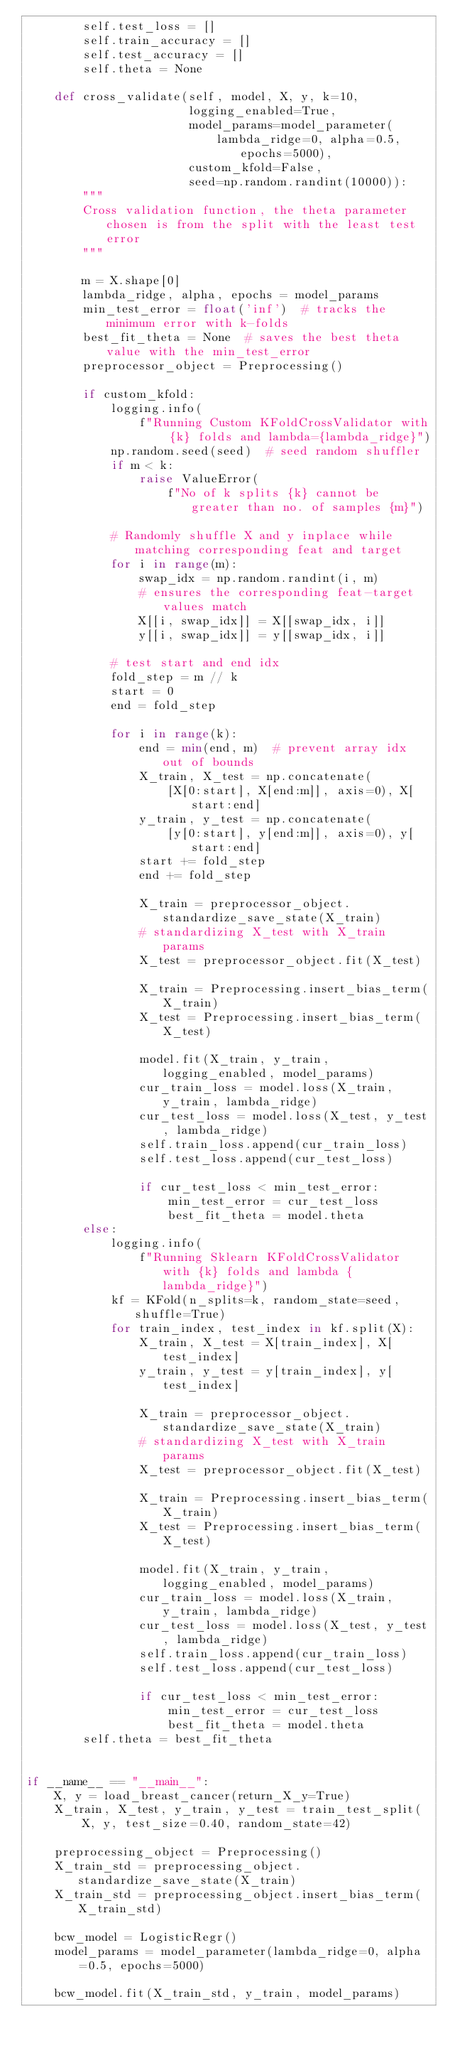<code> <loc_0><loc_0><loc_500><loc_500><_Python_>        self.test_loss = []
        self.train_accuracy = []
        self.test_accuracy = []
        self.theta = None

    def cross_validate(self, model, X, y, k=10,
                       logging_enabled=True,
                       model_params=model_parameter(
                           lambda_ridge=0, alpha=0.5, epochs=5000),
                       custom_kfold=False,
                       seed=np.random.randint(10000)):
        """
        Cross validation function, the theta parameter chosen is from the split with the least test error
        """

        m = X.shape[0]
        lambda_ridge, alpha, epochs = model_params
        min_test_error = float('inf')  # tracks the minimum error with k-folds
        best_fit_theta = None  # saves the best theta value with the min_test_error
        preprocessor_object = Preprocessing()

        if custom_kfold:
            logging.info(
                f"Running Custom KFoldCrossValidator with {k} folds and lambda={lambda_ridge}")
            np.random.seed(seed)  # seed random shuffler
            if m < k:
                raise ValueError(
                    f"No of k splits {k} cannot be greater than no. of samples {m}")

            # Randomly shuffle X and y inplace while matching corresponding feat and target
            for i in range(m):
                swap_idx = np.random.randint(i, m)
                # ensures the corresponding feat-target values match
                X[[i, swap_idx]] = X[[swap_idx, i]]
                y[[i, swap_idx]] = y[[swap_idx, i]]

            # test start and end idx
            fold_step = m // k
            start = 0
            end = fold_step

            for i in range(k):
                end = min(end, m)  # prevent array idx out of bounds
                X_train, X_test = np.concatenate(
                    [X[0:start], X[end:m]], axis=0), X[start:end]
                y_train, y_test = np.concatenate(
                    [y[0:start], y[end:m]], axis=0), y[start:end]
                start += fold_step
                end += fold_step

                X_train = preprocessor_object.standardize_save_state(X_train)
                # standardizing X_test with X_train params
                X_test = preprocessor_object.fit(X_test)

                X_train = Preprocessing.insert_bias_term(X_train)
                X_test = Preprocessing.insert_bias_term(X_test)

                model.fit(X_train, y_train, logging_enabled, model_params)
                cur_train_loss = model.loss(X_train, y_train, lambda_ridge)
                cur_test_loss = model.loss(X_test, y_test, lambda_ridge)
                self.train_loss.append(cur_train_loss)
                self.test_loss.append(cur_test_loss)

                if cur_test_loss < min_test_error:
                    min_test_error = cur_test_loss
                    best_fit_theta = model.theta
        else:
            logging.info(
                f"Running Sklearn KFoldCrossValidator with {k} folds and lambda {lambda_ridge}")
            kf = KFold(n_splits=k, random_state=seed, shuffle=True)
            for train_index, test_index in kf.split(X):
                X_train, X_test = X[train_index], X[test_index]
                y_train, y_test = y[train_index], y[test_index]

                X_train = preprocessor_object.standardize_save_state(X_train)
                # standardizing X_test with X_train params
                X_test = preprocessor_object.fit(X_test)

                X_train = Preprocessing.insert_bias_term(X_train)
                X_test = Preprocessing.insert_bias_term(X_test)

                model.fit(X_train, y_train, logging_enabled, model_params)
                cur_train_loss = model.loss(X_train, y_train, lambda_ridge)
                cur_test_loss = model.loss(X_test, y_test, lambda_ridge)
                self.train_loss.append(cur_train_loss)
                self.test_loss.append(cur_test_loss)

                if cur_test_loss < min_test_error:
                    min_test_error = cur_test_loss
                    best_fit_theta = model.theta
        self.theta = best_fit_theta


if __name__ == "__main__":
    X, y = load_breast_cancer(return_X_y=True)
    X_train, X_test, y_train, y_test = train_test_split(
        X, y, test_size=0.40, random_state=42)

    preprocessing_object = Preprocessing()
    X_train_std = preprocessing_object.standardize_save_state(X_train)
    X_train_std = preprocessing_object.insert_bias_term(X_train_std)

    bcw_model = LogisticRegr()
    model_params = model_parameter(lambda_ridge=0, alpha=0.5, epochs=5000)

    bcw_model.fit(X_train_std, y_train, model_params)
</code> 